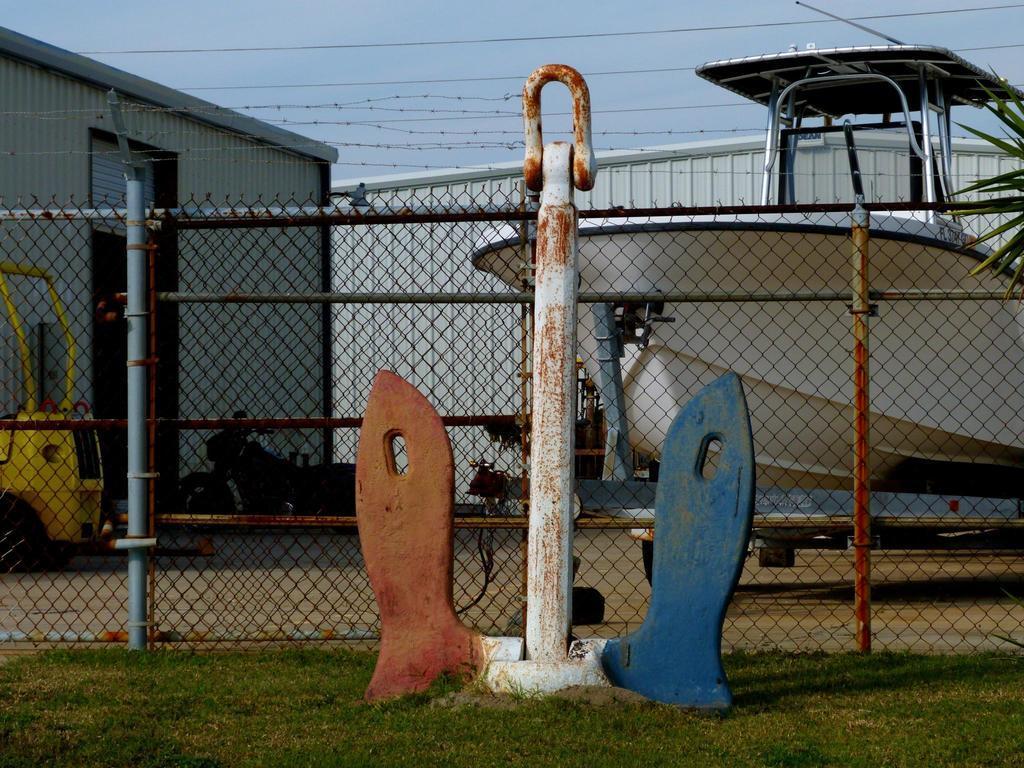In one or two sentences, can you explain what this image depicts? In this image in the center there is a pole and there are stands. In the background there is a fence and there is a boat. On the left side there is a container and vehicle which is yellow in colour and in front of the container there is a bike. Stand and the sky is cloudy. On the ground there is grass. 